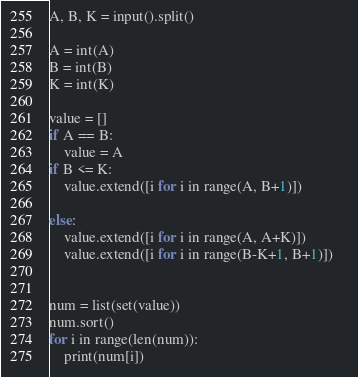<code> <loc_0><loc_0><loc_500><loc_500><_Python_>A, B, K = input().split()

A = int(A)
B = int(B)
K = int(K)

value = []
if A == B:
    value = A
if B <= K:
    value.extend([i for i in range(A, B+1)])

else:
    value.extend([i for i in range(A, A+K)])
    value.extend([i for i in range(B-K+1, B+1)])    


num = list(set(value))
num.sort()
for i in range(len(num)):
    print(num[i])</code> 